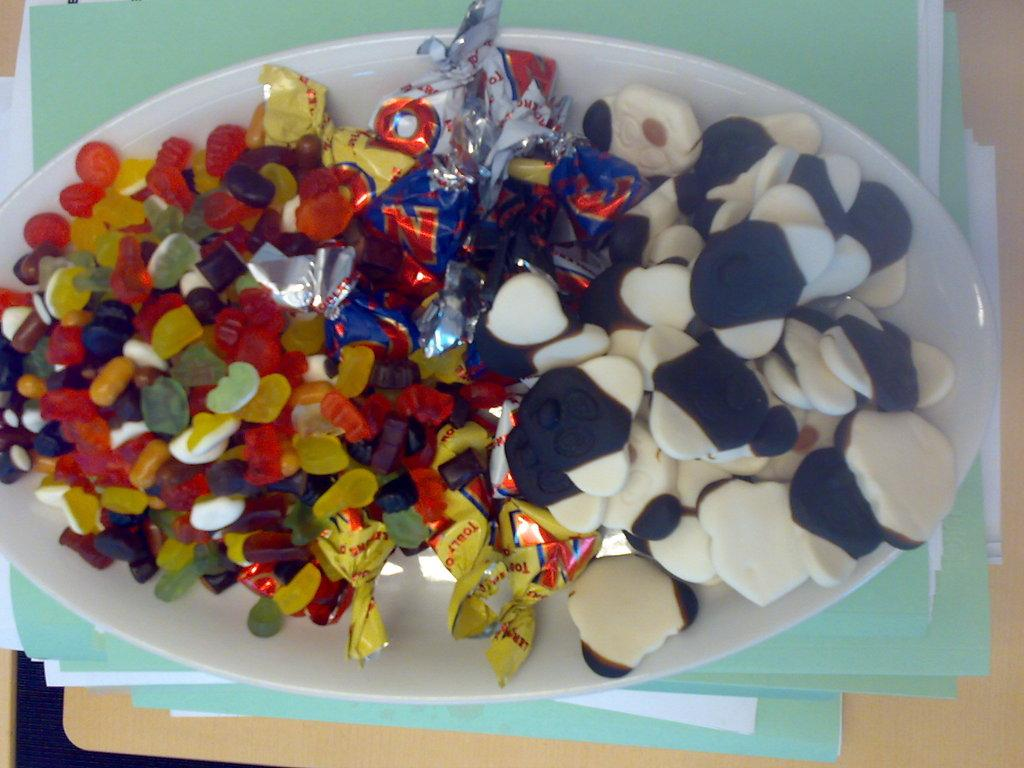What is on the plate that is visible in the image? There is food on a plate in the image. Where is the plate located in the image? The plate is placed on files. What else can be seen on the table in the image? There are files on a table in the image. What month is it in the image? The month cannot be determined from the image, as there is no information about the date or time of year. --- 